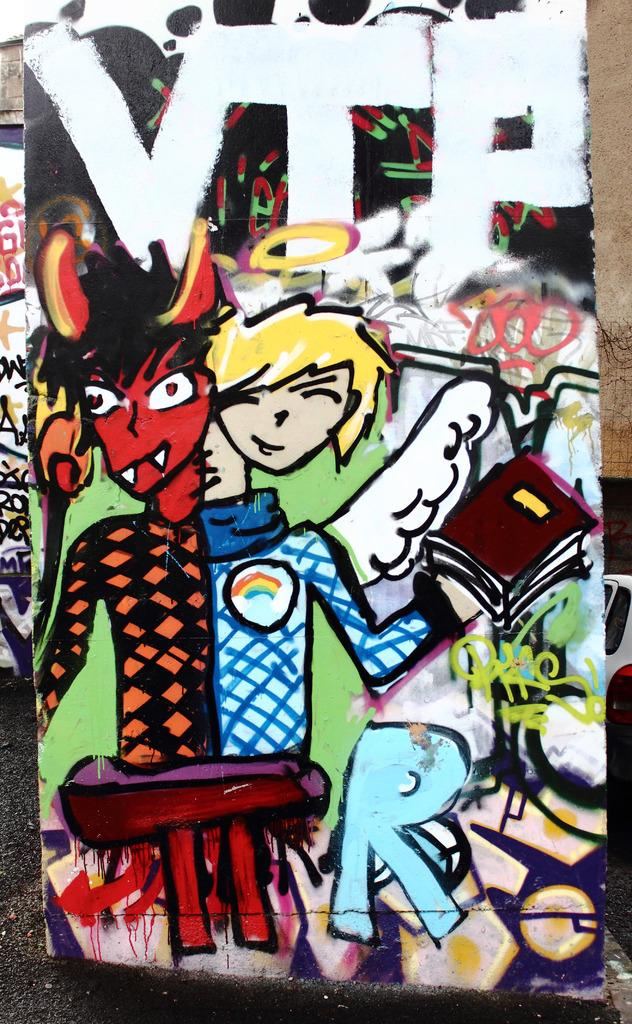What is the main subject of the image? There is a painting in the image. What is depicted in the painting? The painting features a boy. Can you describe the boy in the painting? The boy has horns and wings. What is the boy holding in the painting? The boy is holding a book. Is there any text or writing in the image? Yes, there is text or writing in the image. How many pies are visible on the bridge in the image? There is no bridge or pies present in the image. What type of gate can be seen in the painting? There is no gate depicted in the painting; it features a boy with horns and wings holding a book. 